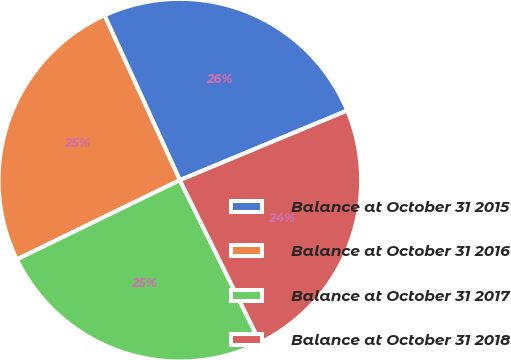<chart> <loc_0><loc_0><loc_500><loc_500><pie_chart><fcel>Balance at October 31 2015<fcel>Balance at October 31 2016<fcel>Balance at October 31 2017<fcel>Balance at October 31 2018<nl><fcel>25.55%<fcel>25.38%<fcel>25.11%<fcel>23.96%<nl></chart> 